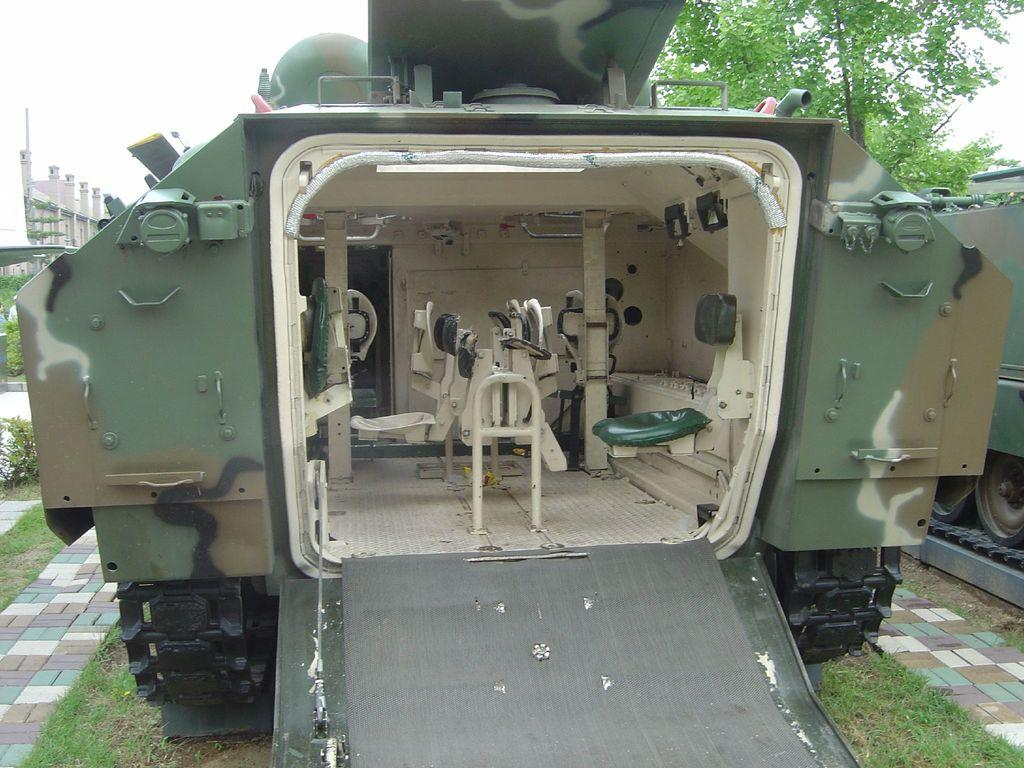What is the main subject in the center of the image? There is a vehicle in the center of the image. From which angle is the vehicle being viewed? The vehicle is viewed from the back. What can be seen in the background of the image? There are trees and buildings in the background of the image. Where is the trick being performed in the image? There is no trick being performed in the image; it features a vehicle viewed from the back. What type of flame can be seen coming from the vehicle's exhaust in the image? There is no flame visible in the image; it only shows a vehicle viewed from the back. 